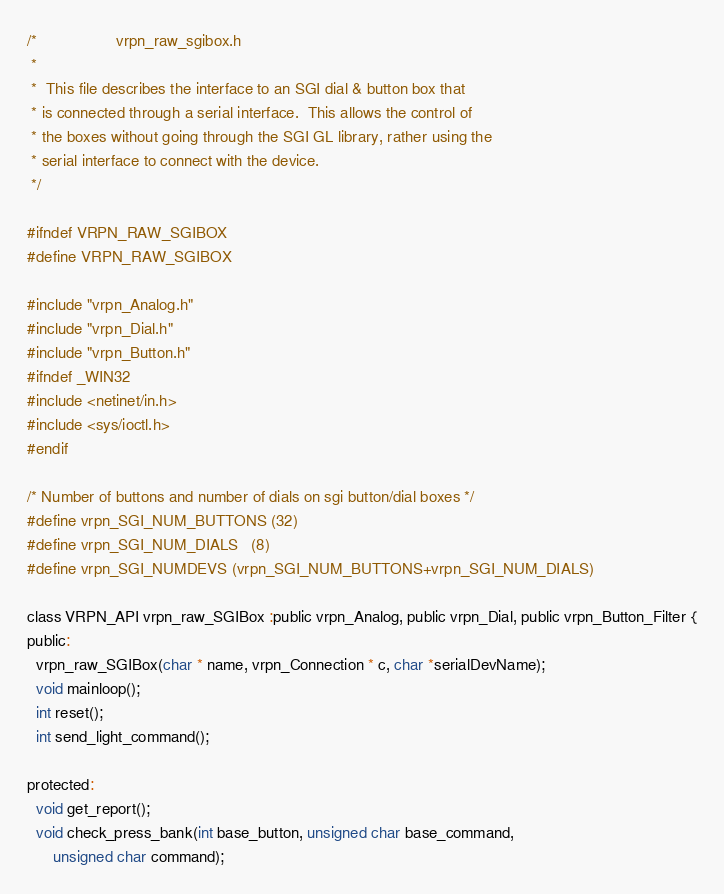Convert code to text. <code><loc_0><loc_0><loc_500><loc_500><_C_>/*					vrpn_raw_sgibox.h
 *	
 *	This file describes the interface to an SGI dial & button box that
 * is connected through a serial interface.  This allows the control of
 * the boxes without going through the SGI GL library, rather using the
 * serial interface to connect with the device.
 */

#ifndef VRPN_RAW_SGIBOX
#define VRPN_RAW_SGIBOX

#include "vrpn_Analog.h"
#include "vrpn_Dial.h"
#include "vrpn_Button.h"
#ifndef _WIN32 
#include <netinet/in.h>
#include <sys/ioctl.h>
#endif

/* Number of buttons and number of dials on sgi button/dial boxes */
#define vrpn_SGI_NUM_BUTTONS (32)
#define vrpn_SGI_NUM_DIALS   (8)
#define vrpn_SGI_NUMDEVS (vrpn_SGI_NUM_BUTTONS+vrpn_SGI_NUM_DIALS)

class VRPN_API vrpn_raw_SGIBox :public vrpn_Analog, public vrpn_Dial, public vrpn_Button_Filter {
public:
  vrpn_raw_SGIBox(char * name, vrpn_Connection * c, char *serialDevName);
  void mainloop();
  int reset();
  int send_light_command();

protected:
  void get_report();
  void check_press_bank(int base_button, unsigned char base_command,
	  unsigned char command);</code> 